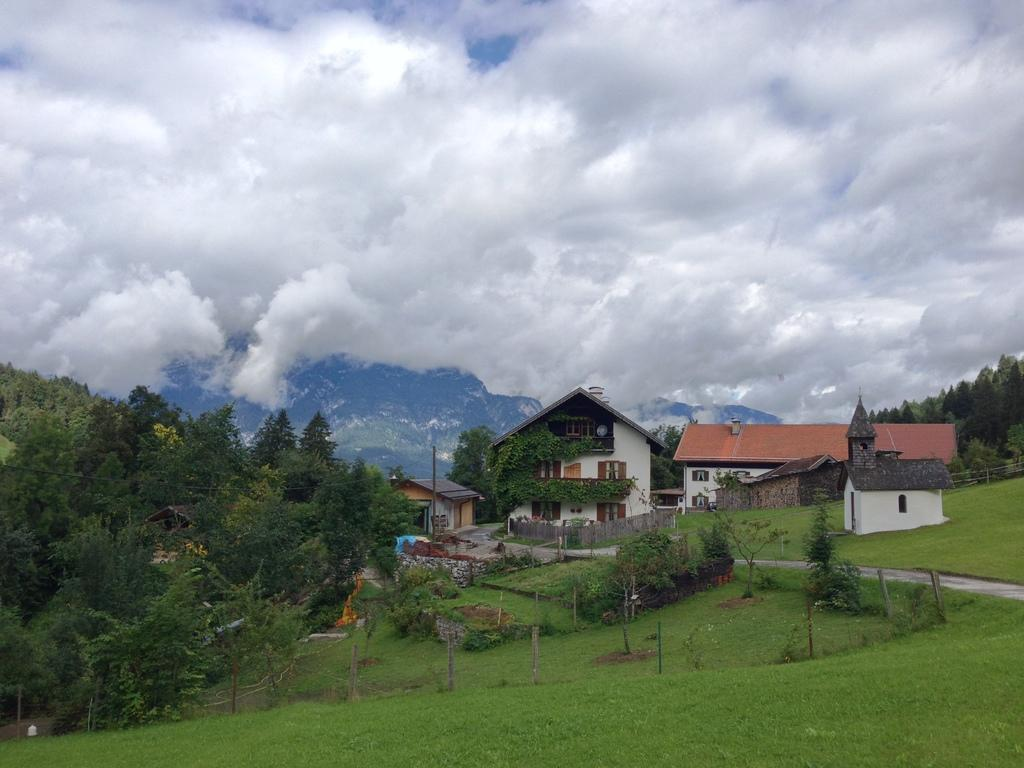What type of structures can be seen in the image? There are houses in the image. What type of vegetation is present in the image? There are trees and grass in the image. What architectural features can be seen in the image? Windows and poles are visible in the image. What is the ground surface like in the image? There is a road in the image. What can be seen in the sky in the background of the image? The sky is visible in the background of the image, and clouds are present. What type of music can be heard playing in the background of the image? There is no music present in the image, as it is a still photograph. Is there a turkey visible in the image? No, there is no turkey present in the image. 